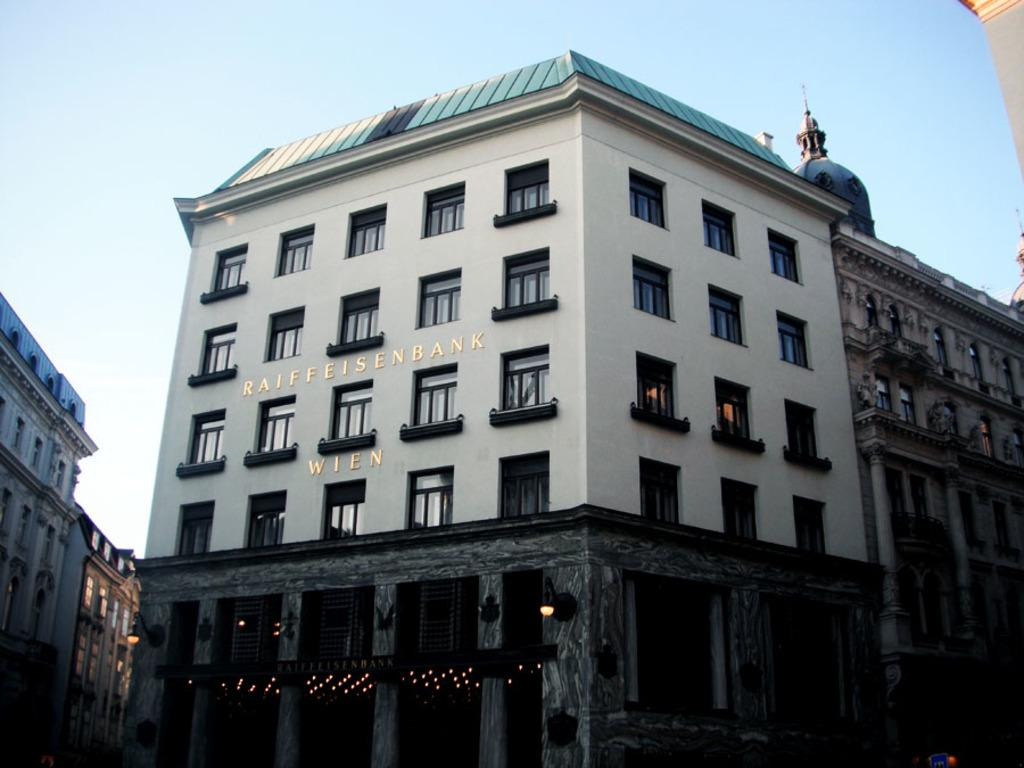What type of structures can be seen in the image? There are buildings in the image. What else is visible in the image besides the buildings? There are lights and other objects in the image. What can be seen in the background of the image? The sky is visible in the background of the image. How many sisters are present in the image? There is no mention of a sister or any people in the image, so it cannot be determined if there are any sisters present. 